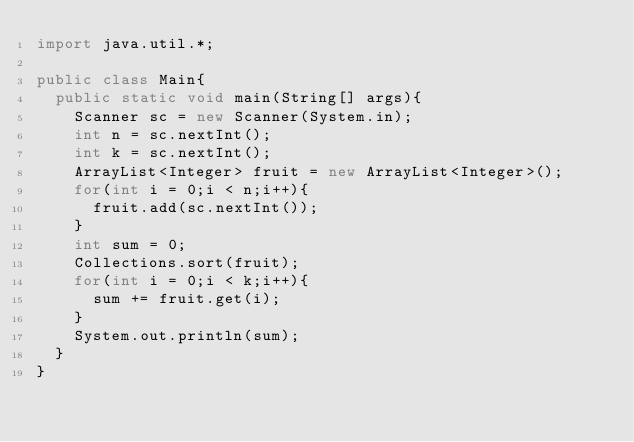<code> <loc_0><loc_0><loc_500><loc_500><_Java_>import java.util.*;
 
public class Main{
  public static void main(String[] args){
    Scanner sc = new Scanner(System.in);
    int n = sc.nextInt();
    int k = sc.nextInt();
    ArrayList<Integer> fruit = new ArrayList<Integer>();
    for(int i = 0;i < n;i++){
      fruit.add(sc.nextInt());
    }
    int sum = 0;
    Collections.sort(fruit);
    for(int i = 0;i < k;i++){
      sum += fruit.get(i);
    }
    System.out.println(sum);
  }
}</code> 